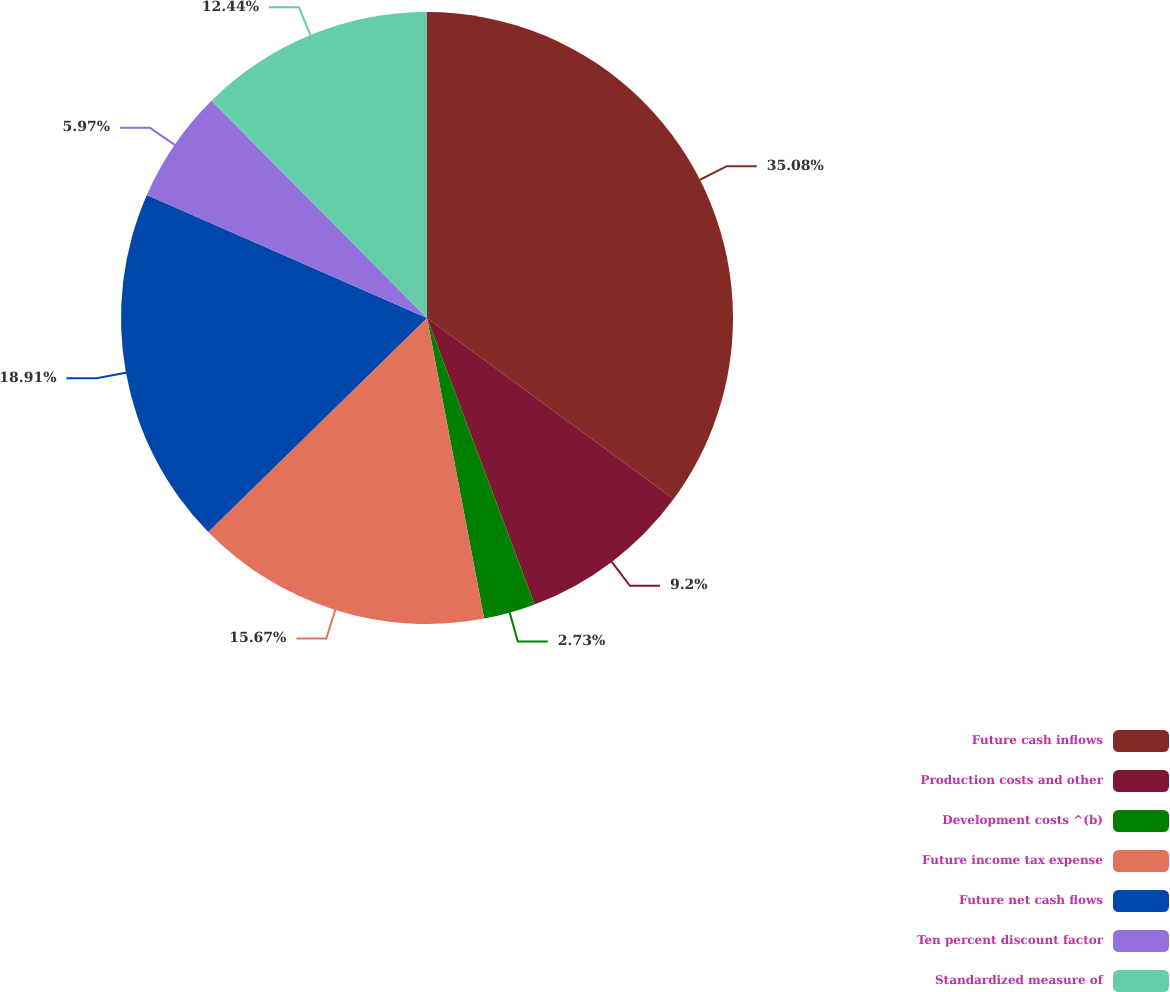<chart> <loc_0><loc_0><loc_500><loc_500><pie_chart><fcel>Future cash inflows<fcel>Production costs and other<fcel>Development costs ^(b)<fcel>Future income tax expense<fcel>Future net cash flows<fcel>Ten percent discount factor<fcel>Standardized measure of<nl><fcel>35.08%<fcel>9.2%<fcel>2.73%<fcel>15.67%<fcel>18.91%<fcel>5.97%<fcel>12.44%<nl></chart> 